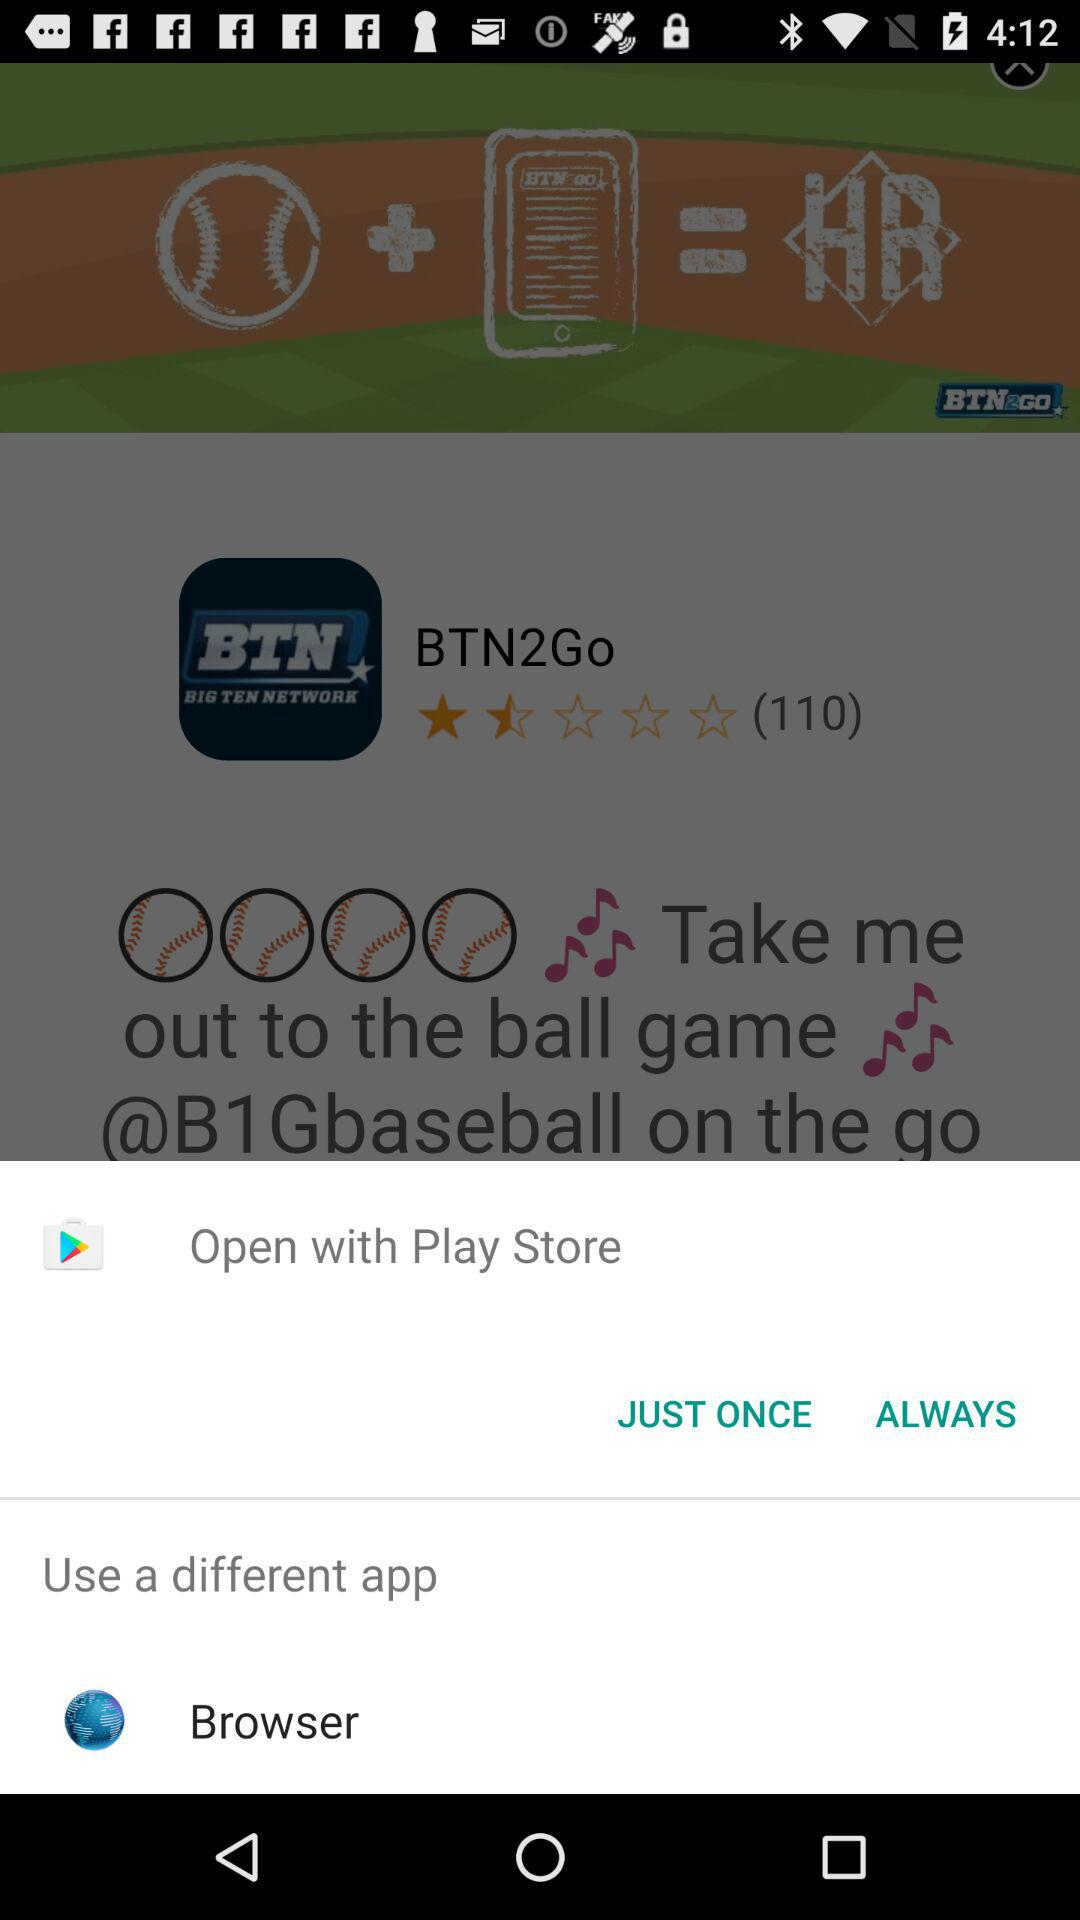Which different applications can we use to open? The different application that you can use to open is "Browser". 